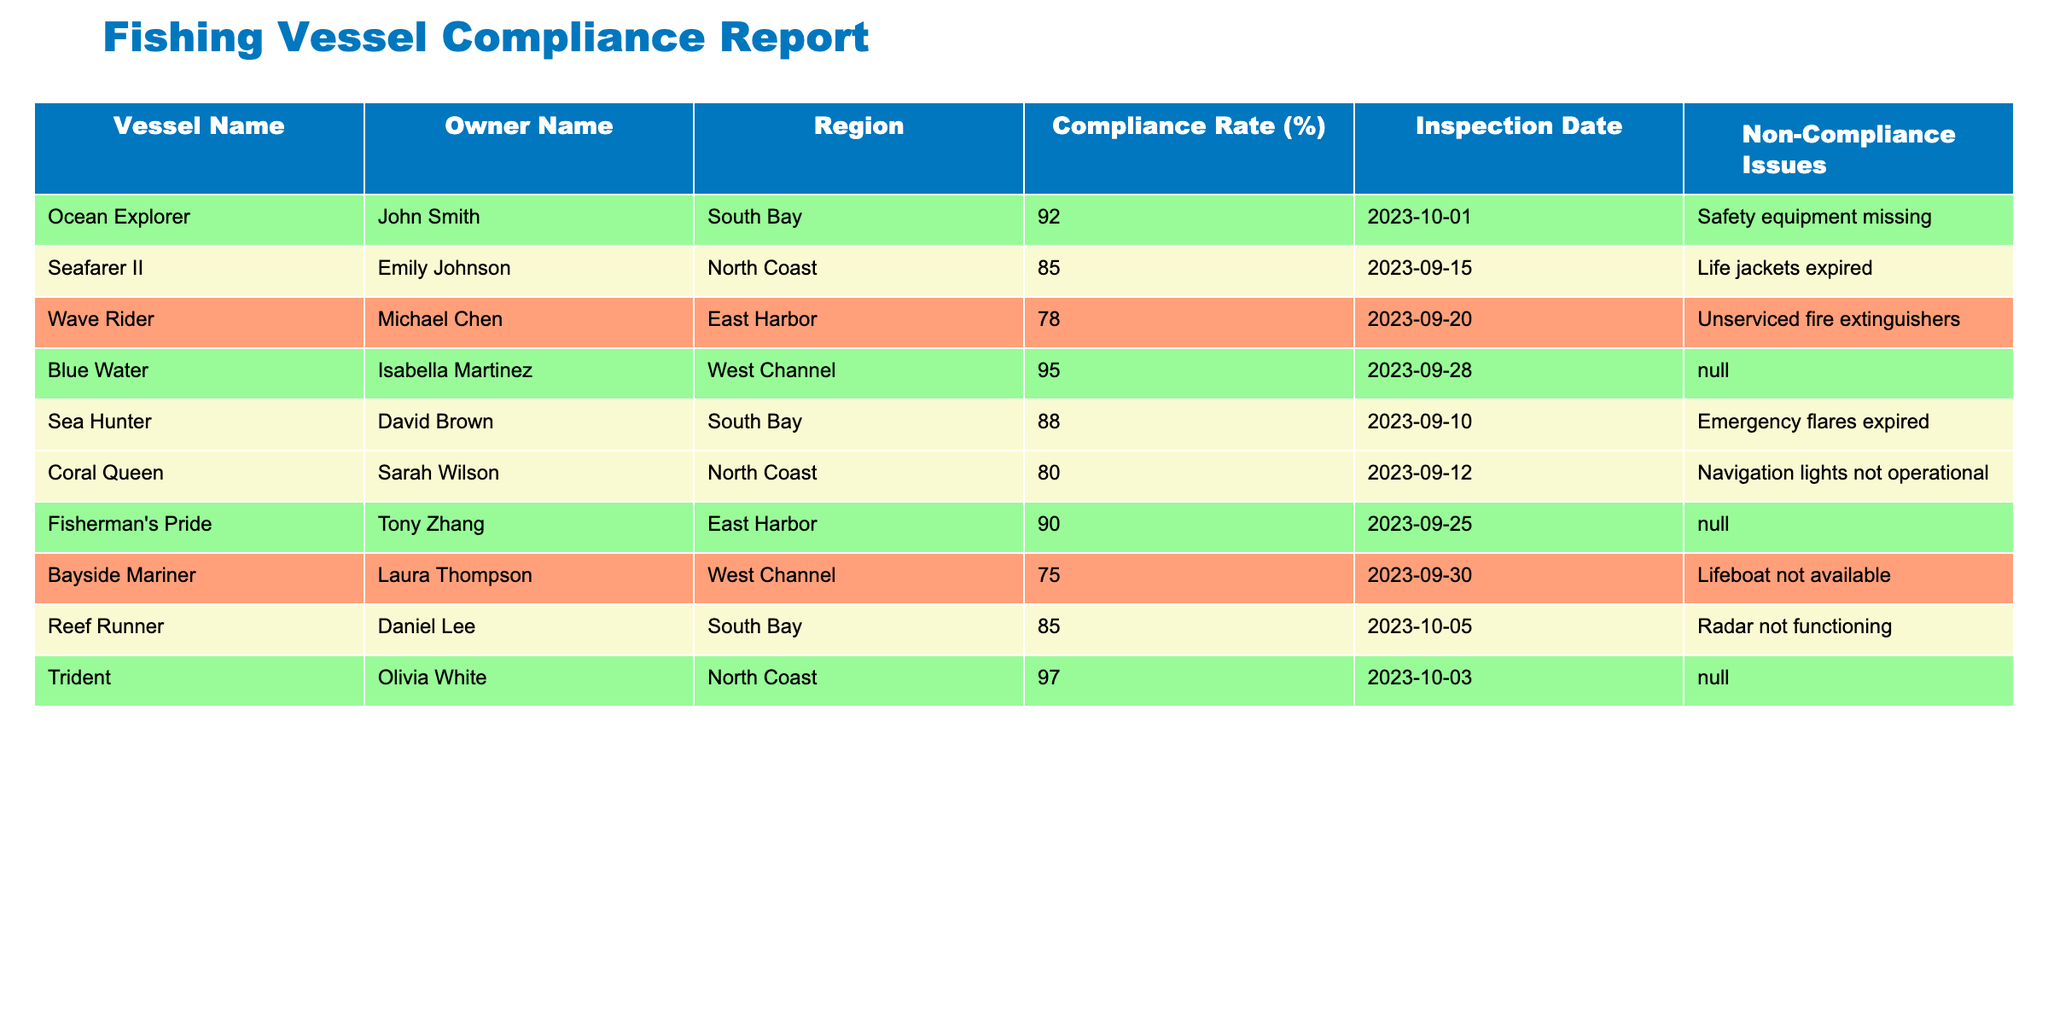What is the compliance rate for the vessel "Ocean Explorer"? The table lists the compliance rate for "Ocean Explorer" as 92%.
Answer: 92% Which vessel has the lowest compliance rate? By checking the compliance rates, "Bayside Mariner" shows the lowest rate at 75%.
Answer: Bayside Mariner How many vessels have a compliance rate of 90% or above? The vessels meeting this criterion are "Ocean Explorer," "Blue Water," "Fisherman's Pride," and "Trident," making a total of 4 vessels.
Answer: 4 Is "Coral Queen" compliant with the safety regulations? "Coral Queen" has a compliance rate of 80%, which is below 90% but above 75%, indicating partial compliance.
Answer: No What is the average compliance rate of all vessels listed in the table? Calculating the average: (92 + 85 + 78 + 95 + 88 + 80 + 90 + 75 + 85 + 97) results in a sum of 90.
Answer: 90 Which region has the highest compliance rate among its vessels? By comparing regions, "North Coast" has "Trident" at 97%, the highest among all regions, thus North Coast is identified as having the highest compliance rate.
Answer: North Coast How many non-compliance issues were identified for "Seafarer II"? "Seafarer II" has one identified non-compliance issue, which is the expiration of life jackets.
Answer: 1 Is there a vessel in the table with a compliance rate of exactly 85%? Yes, "Seafarer II" and "Reef Runner" both have a compliance rate of exactly 85%.
Answer: Yes What percentage of the inspected vessels do not have any non-compliance issues? "Blue Water," "Fisherman's Pride," and "Trident" have no non-compliance issues; thus, there are 3 compliant vessels out of 10 inspected, making it 30%.
Answer: 30% 